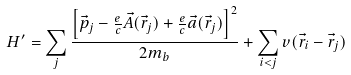Convert formula to latex. <formula><loc_0><loc_0><loc_500><loc_500>H ^ { \prime } = \sum _ { j } \frac { \left [ \vec { p } _ { j } - \frac { e } { c } \vec { A } ( \vec { r } _ { j } ) + \frac { e } { c } \vec { a } ( \vec { r } _ { j } ) \right ] ^ { 2 } } { 2 m _ { b } } + \sum _ { i < j } v ( \vec { r } _ { i } - \vec { r } _ { j } )</formula> 